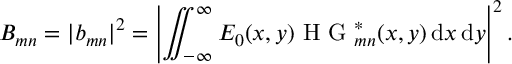<formula> <loc_0><loc_0><loc_500><loc_500>B _ { m n } = | b _ { m n } | ^ { 2 } = \left | \iint _ { - \infty } ^ { \infty } E _ { 0 } ( x , y ) H G _ { m n } ^ { * } ( x , y ) \, d x \, d y \right | ^ { 2 } .</formula> 